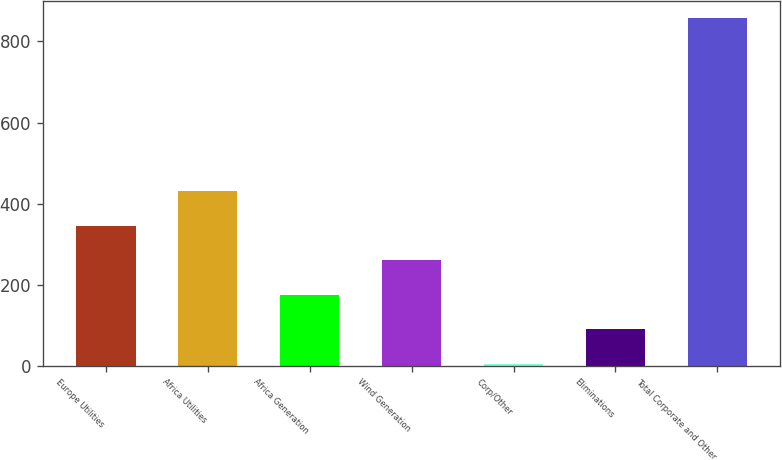<chart> <loc_0><loc_0><loc_500><loc_500><bar_chart><fcel>Europe Utilities<fcel>Africa Utilities<fcel>Africa Generation<fcel>Wind Generation<fcel>Corp/Other<fcel>Eliminations<fcel>Total Corporate and Other<nl><fcel>345.6<fcel>431<fcel>174.8<fcel>260.2<fcel>4<fcel>89.4<fcel>858<nl></chart> 